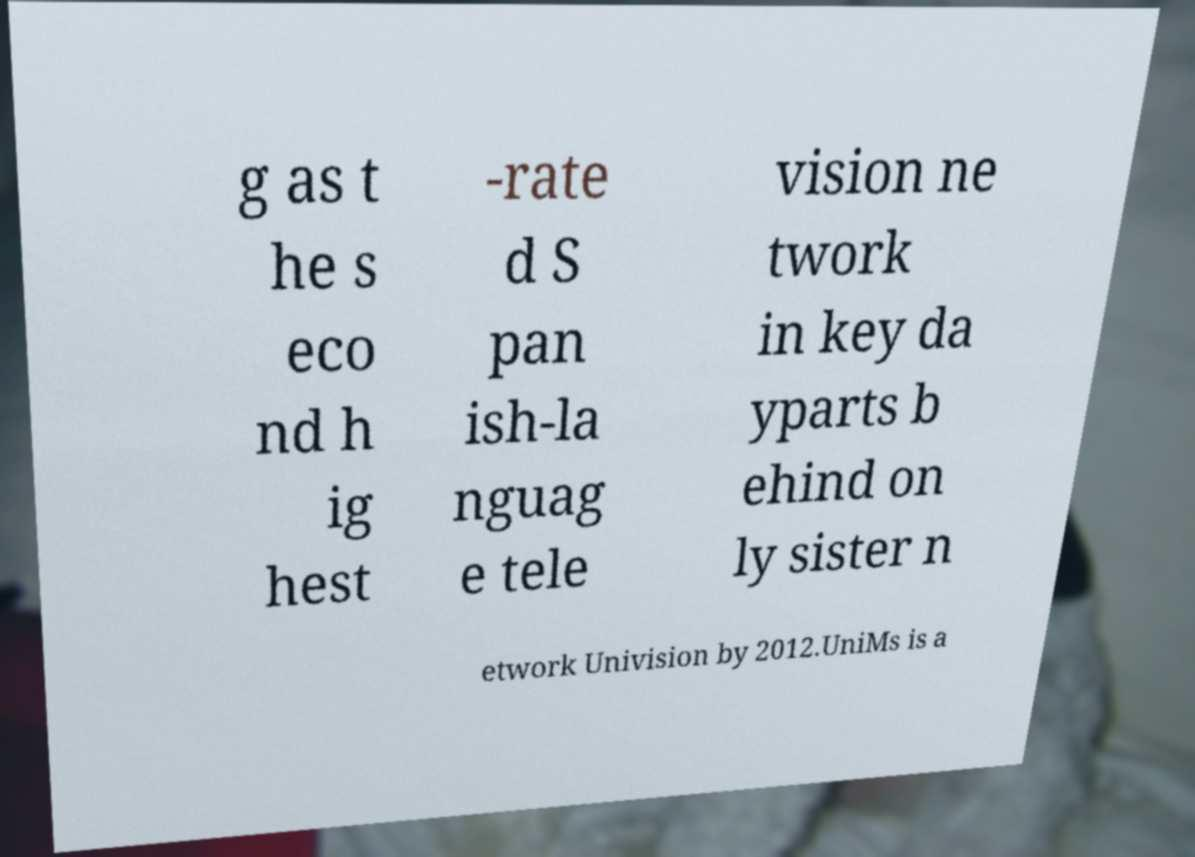For documentation purposes, I need the text within this image transcribed. Could you provide that? g as t he s eco nd h ig hest -rate d S pan ish-la nguag e tele vision ne twork in key da yparts b ehind on ly sister n etwork Univision by 2012.UniMs is a 